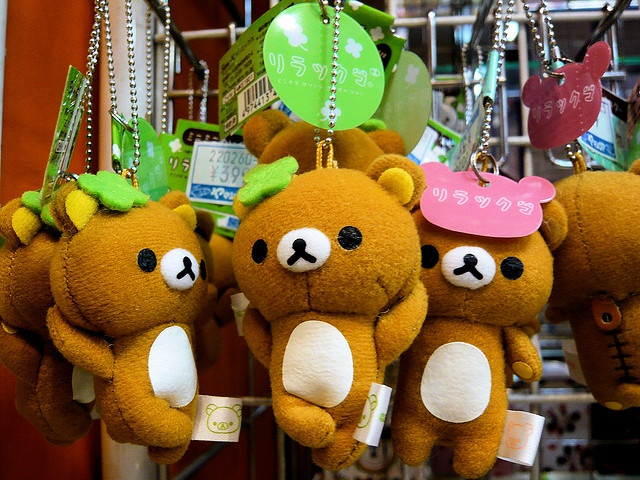Describe the objects in this image and their specific colors. I can see teddy bear in lightblue, olive, orange, maroon, and lightgray tones, teddy bear in lightblue, olive, orange, maroon, and lightgray tones, teddy bear in lightblue, maroon, olive, black, and lightgray tones, teddy bear in lightblue, black, maroon, olive, and orange tones, and teddy bear in lightblue, black, maroon, olive, and orange tones in this image. 